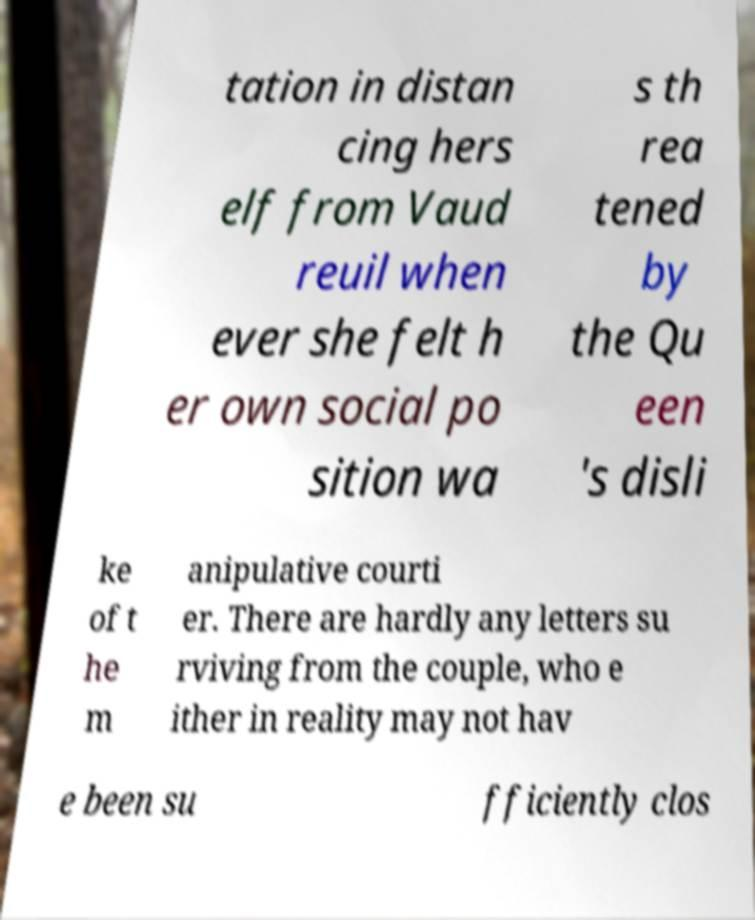For documentation purposes, I need the text within this image transcribed. Could you provide that? tation in distan cing hers elf from Vaud reuil when ever she felt h er own social po sition wa s th rea tened by the Qu een 's disli ke of t he m anipulative courti er. There are hardly any letters su rviving from the couple, who e ither in reality may not hav e been su fficiently clos 